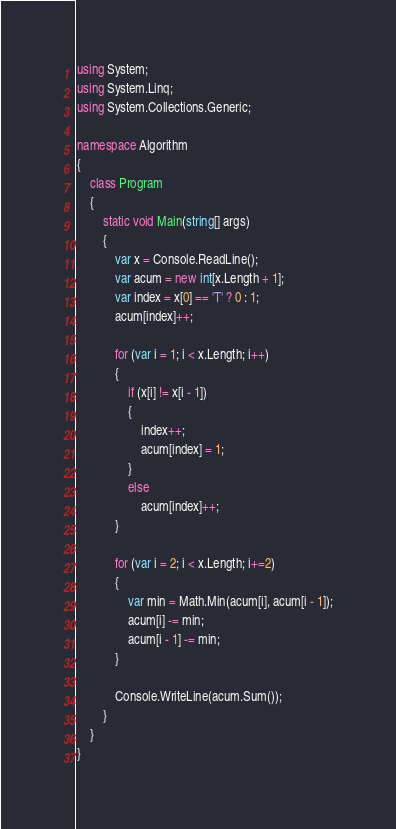<code> <loc_0><loc_0><loc_500><loc_500><_C#_>using System;
using System.Linq;
using System.Collections.Generic;

namespace Algorithm
{
    class Program
    {
        static void Main(string[] args)
        {
            var x = Console.ReadLine();
            var acum = new int[x.Length + 1];
            var index = x[0] == 'T' ? 0 : 1;
            acum[index]++;

            for (var i = 1; i < x.Length; i++)
            {
                if (x[i] != x[i - 1])
                {
                    index++;
                    acum[index] = 1;
                }
                else
                    acum[index]++;
            }

            for (var i = 2; i < x.Length; i+=2)
            {
                var min = Math.Min(acum[i], acum[i - 1]);
                acum[i] -= min;
                acum[i - 1] -= min;
            }

            Console.WriteLine(acum.Sum());
        }
    }
}
</code> 